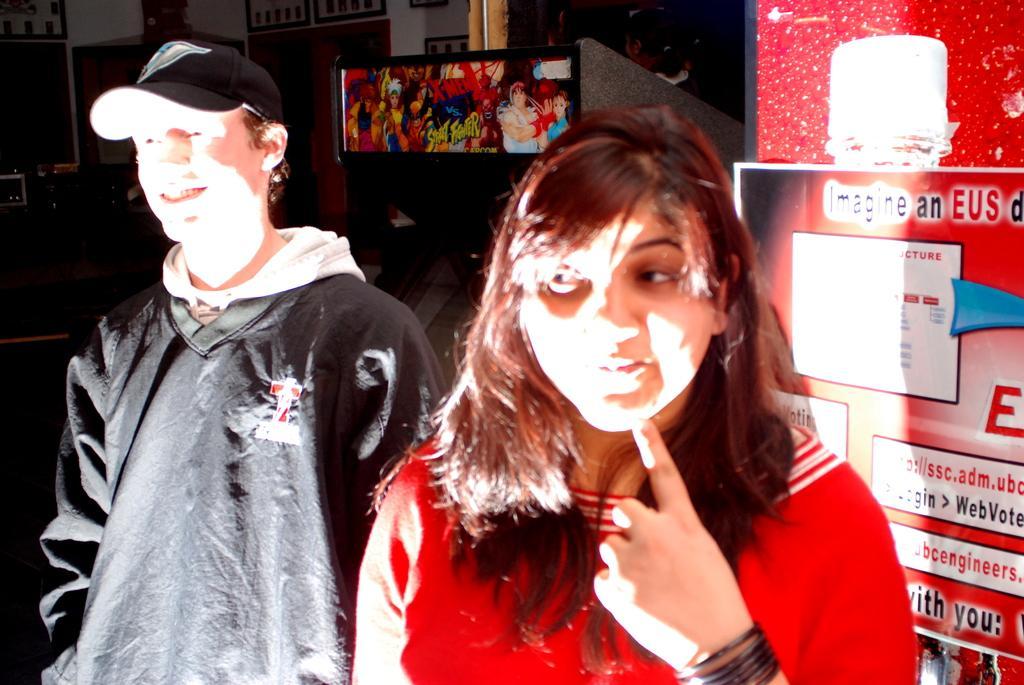Please provide a concise description of this image. In this image there is a boy and girl standing together, behind them there is a screen and also there poster on the wall. 